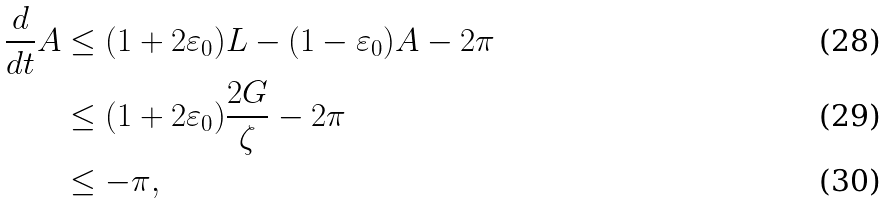<formula> <loc_0><loc_0><loc_500><loc_500>\frac { d } { d t } A & \leq ( 1 + 2 \varepsilon _ { 0 } ) L - ( 1 - \varepsilon _ { 0 } ) A - 2 \pi \\ & \leq ( 1 + 2 \varepsilon _ { 0 } ) \frac { 2 G } { \zeta } - 2 \pi \\ & \leq - \pi ,</formula> 